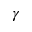<formula> <loc_0><loc_0><loc_500><loc_500>\gamma</formula> 